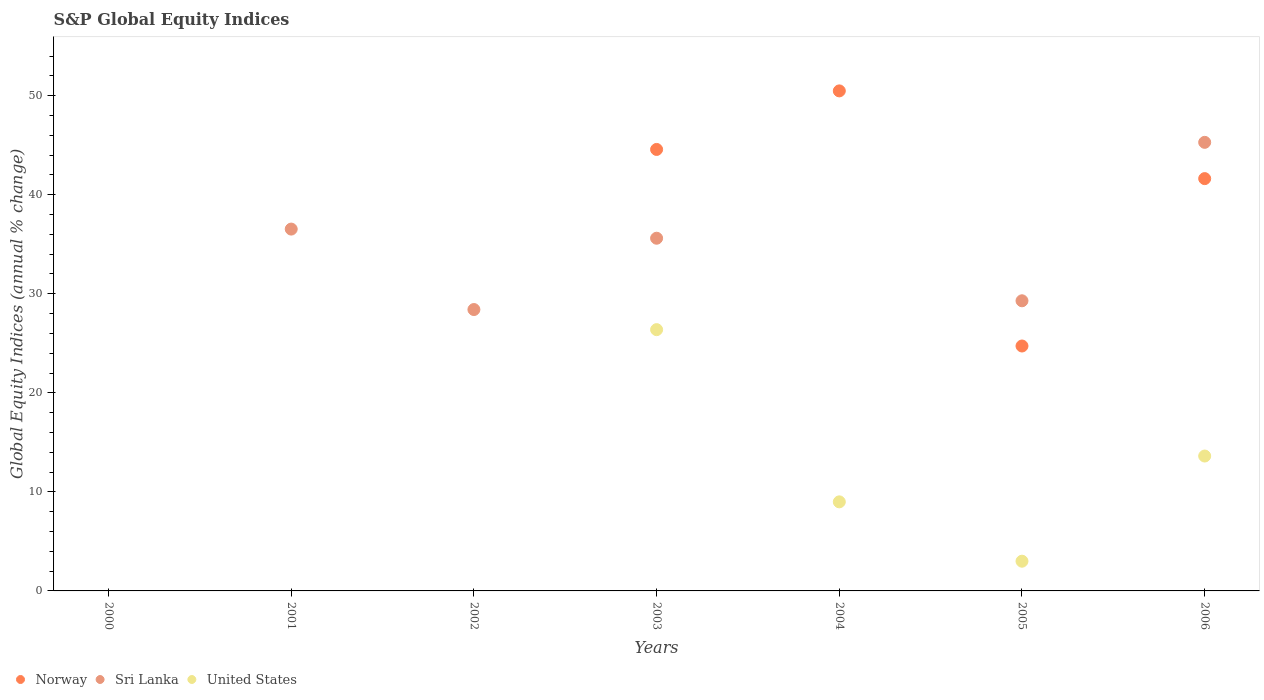How many different coloured dotlines are there?
Your answer should be compact. 3. Is the number of dotlines equal to the number of legend labels?
Your answer should be compact. No. Across all years, what is the maximum global equity indices in Sri Lanka?
Make the answer very short. 45.29. Across all years, what is the minimum global equity indices in Norway?
Your answer should be compact. 0. In which year was the global equity indices in United States maximum?
Your answer should be compact. 2003. What is the total global equity indices in United States in the graph?
Your response must be concise. 51.99. What is the difference between the global equity indices in Sri Lanka in 2003 and that in 2006?
Your answer should be compact. -9.68. What is the difference between the global equity indices in Sri Lanka in 2005 and the global equity indices in Norway in 2001?
Offer a very short reply. 29.29. What is the average global equity indices in Sri Lanka per year?
Offer a very short reply. 25.02. In the year 2003, what is the difference between the global equity indices in Norway and global equity indices in Sri Lanka?
Provide a short and direct response. 8.96. In how many years, is the global equity indices in United States greater than 52 %?
Offer a terse response. 0. What is the ratio of the global equity indices in United States in 2003 to that in 2005?
Make the answer very short. 8.79. Is the global equity indices in United States in 2004 less than that in 2005?
Ensure brevity in your answer.  No. What is the difference between the highest and the second highest global equity indices in United States?
Ensure brevity in your answer.  12.76. What is the difference between the highest and the lowest global equity indices in Sri Lanka?
Your response must be concise. 45.29. Is the global equity indices in United States strictly less than the global equity indices in Norway over the years?
Give a very brief answer. No. How many dotlines are there?
Make the answer very short. 3. How many years are there in the graph?
Ensure brevity in your answer.  7. Are the values on the major ticks of Y-axis written in scientific E-notation?
Provide a succinct answer. No. Does the graph contain any zero values?
Provide a short and direct response. Yes. Does the graph contain grids?
Ensure brevity in your answer.  No. How many legend labels are there?
Provide a succinct answer. 3. What is the title of the graph?
Offer a very short reply. S&P Global Equity Indices. Does "Togo" appear as one of the legend labels in the graph?
Provide a short and direct response. No. What is the label or title of the X-axis?
Make the answer very short. Years. What is the label or title of the Y-axis?
Give a very brief answer. Global Equity Indices (annual % change). What is the Global Equity Indices (annual % change) of Sri Lanka in 2000?
Offer a very short reply. 0. What is the Global Equity Indices (annual % change) in United States in 2000?
Make the answer very short. 0. What is the Global Equity Indices (annual % change) in Norway in 2001?
Make the answer very short. 0. What is the Global Equity Indices (annual % change) of Sri Lanka in 2001?
Offer a terse response. 36.53. What is the Global Equity Indices (annual % change) of United States in 2001?
Your answer should be compact. 0. What is the Global Equity Indices (annual % change) in Sri Lanka in 2002?
Your answer should be compact. 28.41. What is the Global Equity Indices (annual % change) of Norway in 2003?
Your answer should be very brief. 44.57. What is the Global Equity Indices (annual % change) in Sri Lanka in 2003?
Give a very brief answer. 35.61. What is the Global Equity Indices (annual % change) of United States in 2003?
Give a very brief answer. 26.38. What is the Global Equity Indices (annual % change) of Norway in 2004?
Your response must be concise. 50.49. What is the Global Equity Indices (annual % change) in United States in 2004?
Give a very brief answer. 8.99. What is the Global Equity Indices (annual % change) of Norway in 2005?
Give a very brief answer. 24.73. What is the Global Equity Indices (annual % change) of Sri Lanka in 2005?
Your response must be concise. 29.29. What is the Global Equity Indices (annual % change) in United States in 2005?
Offer a very short reply. 3. What is the Global Equity Indices (annual % change) in Norway in 2006?
Offer a terse response. 41.63. What is the Global Equity Indices (annual % change) in Sri Lanka in 2006?
Provide a succinct answer. 45.29. What is the Global Equity Indices (annual % change) in United States in 2006?
Your answer should be compact. 13.62. Across all years, what is the maximum Global Equity Indices (annual % change) of Norway?
Give a very brief answer. 50.49. Across all years, what is the maximum Global Equity Indices (annual % change) of Sri Lanka?
Provide a short and direct response. 45.29. Across all years, what is the maximum Global Equity Indices (annual % change) of United States?
Give a very brief answer. 26.38. Across all years, what is the minimum Global Equity Indices (annual % change) of Norway?
Make the answer very short. 0. Across all years, what is the minimum Global Equity Indices (annual % change) in Sri Lanka?
Make the answer very short. 0. Across all years, what is the minimum Global Equity Indices (annual % change) of United States?
Ensure brevity in your answer.  0. What is the total Global Equity Indices (annual % change) in Norway in the graph?
Give a very brief answer. 161.42. What is the total Global Equity Indices (annual % change) in Sri Lanka in the graph?
Give a very brief answer. 175.14. What is the total Global Equity Indices (annual % change) of United States in the graph?
Make the answer very short. 51.99. What is the difference between the Global Equity Indices (annual % change) in Sri Lanka in 2001 and that in 2002?
Your response must be concise. 8.12. What is the difference between the Global Equity Indices (annual % change) of Sri Lanka in 2001 and that in 2003?
Your response must be concise. 0.92. What is the difference between the Global Equity Indices (annual % change) of Sri Lanka in 2001 and that in 2005?
Keep it short and to the point. 7.24. What is the difference between the Global Equity Indices (annual % change) of Sri Lanka in 2001 and that in 2006?
Provide a succinct answer. -8.76. What is the difference between the Global Equity Indices (annual % change) in Sri Lanka in 2002 and that in 2005?
Your answer should be compact. -0.88. What is the difference between the Global Equity Indices (annual % change) of Sri Lanka in 2002 and that in 2006?
Give a very brief answer. -16.88. What is the difference between the Global Equity Indices (annual % change) in Norway in 2003 and that in 2004?
Provide a succinct answer. -5.91. What is the difference between the Global Equity Indices (annual % change) in United States in 2003 and that in 2004?
Your answer should be very brief. 17.39. What is the difference between the Global Equity Indices (annual % change) in Norway in 2003 and that in 2005?
Provide a succinct answer. 19.85. What is the difference between the Global Equity Indices (annual % change) in Sri Lanka in 2003 and that in 2005?
Your answer should be very brief. 6.32. What is the difference between the Global Equity Indices (annual % change) in United States in 2003 and that in 2005?
Provide a short and direct response. 23.38. What is the difference between the Global Equity Indices (annual % change) of Norway in 2003 and that in 2006?
Make the answer very short. 2.95. What is the difference between the Global Equity Indices (annual % change) in Sri Lanka in 2003 and that in 2006?
Offer a very short reply. -9.68. What is the difference between the Global Equity Indices (annual % change) in United States in 2003 and that in 2006?
Give a very brief answer. 12.76. What is the difference between the Global Equity Indices (annual % change) in Norway in 2004 and that in 2005?
Provide a short and direct response. 25.76. What is the difference between the Global Equity Indices (annual % change) of United States in 2004 and that in 2005?
Ensure brevity in your answer.  5.99. What is the difference between the Global Equity Indices (annual % change) of Norway in 2004 and that in 2006?
Offer a very short reply. 8.86. What is the difference between the Global Equity Indices (annual % change) in United States in 2004 and that in 2006?
Offer a terse response. -4.63. What is the difference between the Global Equity Indices (annual % change) of Norway in 2005 and that in 2006?
Provide a succinct answer. -16.9. What is the difference between the Global Equity Indices (annual % change) of Sri Lanka in 2005 and that in 2006?
Give a very brief answer. -16. What is the difference between the Global Equity Indices (annual % change) of United States in 2005 and that in 2006?
Keep it short and to the point. -10.62. What is the difference between the Global Equity Indices (annual % change) in Sri Lanka in 2001 and the Global Equity Indices (annual % change) in United States in 2003?
Give a very brief answer. 10.15. What is the difference between the Global Equity Indices (annual % change) of Sri Lanka in 2001 and the Global Equity Indices (annual % change) of United States in 2004?
Your response must be concise. 27.54. What is the difference between the Global Equity Indices (annual % change) in Sri Lanka in 2001 and the Global Equity Indices (annual % change) in United States in 2005?
Provide a succinct answer. 33.53. What is the difference between the Global Equity Indices (annual % change) of Sri Lanka in 2001 and the Global Equity Indices (annual % change) of United States in 2006?
Provide a short and direct response. 22.91. What is the difference between the Global Equity Indices (annual % change) of Sri Lanka in 2002 and the Global Equity Indices (annual % change) of United States in 2003?
Provide a succinct answer. 2.03. What is the difference between the Global Equity Indices (annual % change) in Sri Lanka in 2002 and the Global Equity Indices (annual % change) in United States in 2004?
Offer a terse response. 19.42. What is the difference between the Global Equity Indices (annual % change) in Sri Lanka in 2002 and the Global Equity Indices (annual % change) in United States in 2005?
Offer a terse response. 25.41. What is the difference between the Global Equity Indices (annual % change) of Sri Lanka in 2002 and the Global Equity Indices (annual % change) of United States in 2006?
Offer a very short reply. 14.79. What is the difference between the Global Equity Indices (annual % change) of Norway in 2003 and the Global Equity Indices (annual % change) of United States in 2004?
Your answer should be very brief. 35.58. What is the difference between the Global Equity Indices (annual % change) in Sri Lanka in 2003 and the Global Equity Indices (annual % change) in United States in 2004?
Give a very brief answer. 26.62. What is the difference between the Global Equity Indices (annual % change) of Norway in 2003 and the Global Equity Indices (annual % change) of Sri Lanka in 2005?
Make the answer very short. 15.28. What is the difference between the Global Equity Indices (annual % change) in Norway in 2003 and the Global Equity Indices (annual % change) in United States in 2005?
Your answer should be very brief. 41.57. What is the difference between the Global Equity Indices (annual % change) of Sri Lanka in 2003 and the Global Equity Indices (annual % change) of United States in 2005?
Provide a short and direct response. 32.61. What is the difference between the Global Equity Indices (annual % change) in Norway in 2003 and the Global Equity Indices (annual % change) in Sri Lanka in 2006?
Offer a terse response. -0.72. What is the difference between the Global Equity Indices (annual % change) in Norway in 2003 and the Global Equity Indices (annual % change) in United States in 2006?
Your answer should be compact. 30.96. What is the difference between the Global Equity Indices (annual % change) in Sri Lanka in 2003 and the Global Equity Indices (annual % change) in United States in 2006?
Keep it short and to the point. 21.99. What is the difference between the Global Equity Indices (annual % change) of Norway in 2004 and the Global Equity Indices (annual % change) of Sri Lanka in 2005?
Keep it short and to the point. 21.19. What is the difference between the Global Equity Indices (annual % change) in Norway in 2004 and the Global Equity Indices (annual % change) in United States in 2005?
Offer a very short reply. 47.48. What is the difference between the Global Equity Indices (annual % change) in Norway in 2004 and the Global Equity Indices (annual % change) in Sri Lanka in 2006?
Keep it short and to the point. 5.19. What is the difference between the Global Equity Indices (annual % change) in Norway in 2004 and the Global Equity Indices (annual % change) in United States in 2006?
Keep it short and to the point. 36.87. What is the difference between the Global Equity Indices (annual % change) of Norway in 2005 and the Global Equity Indices (annual % change) of Sri Lanka in 2006?
Offer a terse response. -20.56. What is the difference between the Global Equity Indices (annual % change) in Norway in 2005 and the Global Equity Indices (annual % change) in United States in 2006?
Make the answer very short. 11.11. What is the difference between the Global Equity Indices (annual % change) in Sri Lanka in 2005 and the Global Equity Indices (annual % change) in United States in 2006?
Provide a succinct answer. 15.67. What is the average Global Equity Indices (annual % change) of Norway per year?
Ensure brevity in your answer.  23.06. What is the average Global Equity Indices (annual % change) in Sri Lanka per year?
Your response must be concise. 25.02. What is the average Global Equity Indices (annual % change) in United States per year?
Provide a succinct answer. 7.43. In the year 2003, what is the difference between the Global Equity Indices (annual % change) in Norway and Global Equity Indices (annual % change) in Sri Lanka?
Your response must be concise. 8.96. In the year 2003, what is the difference between the Global Equity Indices (annual % change) in Norway and Global Equity Indices (annual % change) in United States?
Offer a very short reply. 18.19. In the year 2003, what is the difference between the Global Equity Indices (annual % change) of Sri Lanka and Global Equity Indices (annual % change) of United States?
Ensure brevity in your answer.  9.23. In the year 2004, what is the difference between the Global Equity Indices (annual % change) in Norway and Global Equity Indices (annual % change) in United States?
Your answer should be compact. 41.49. In the year 2005, what is the difference between the Global Equity Indices (annual % change) in Norway and Global Equity Indices (annual % change) in Sri Lanka?
Your answer should be very brief. -4.57. In the year 2005, what is the difference between the Global Equity Indices (annual % change) of Norway and Global Equity Indices (annual % change) of United States?
Offer a very short reply. 21.73. In the year 2005, what is the difference between the Global Equity Indices (annual % change) of Sri Lanka and Global Equity Indices (annual % change) of United States?
Provide a succinct answer. 26.29. In the year 2006, what is the difference between the Global Equity Indices (annual % change) in Norway and Global Equity Indices (annual % change) in Sri Lanka?
Provide a short and direct response. -3.66. In the year 2006, what is the difference between the Global Equity Indices (annual % change) in Norway and Global Equity Indices (annual % change) in United States?
Make the answer very short. 28.01. In the year 2006, what is the difference between the Global Equity Indices (annual % change) in Sri Lanka and Global Equity Indices (annual % change) in United States?
Offer a very short reply. 31.67. What is the ratio of the Global Equity Indices (annual % change) of Sri Lanka in 2001 to that in 2002?
Provide a succinct answer. 1.29. What is the ratio of the Global Equity Indices (annual % change) of Sri Lanka in 2001 to that in 2003?
Your answer should be compact. 1.03. What is the ratio of the Global Equity Indices (annual % change) of Sri Lanka in 2001 to that in 2005?
Keep it short and to the point. 1.25. What is the ratio of the Global Equity Indices (annual % change) in Sri Lanka in 2001 to that in 2006?
Your answer should be very brief. 0.81. What is the ratio of the Global Equity Indices (annual % change) in Sri Lanka in 2002 to that in 2003?
Keep it short and to the point. 0.8. What is the ratio of the Global Equity Indices (annual % change) of Sri Lanka in 2002 to that in 2005?
Ensure brevity in your answer.  0.97. What is the ratio of the Global Equity Indices (annual % change) of Sri Lanka in 2002 to that in 2006?
Your response must be concise. 0.63. What is the ratio of the Global Equity Indices (annual % change) of Norway in 2003 to that in 2004?
Make the answer very short. 0.88. What is the ratio of the Global Equity Indices (annual % change) in United States in 2003 to that in 2004?
Make the answer very short. 2.93. What is the ratio of the Global Equity Indices (annual % change) of Norway in 2003 to that in 2005?
Your answer should be very brief. 1.8. What is the ratio of the Global Equity Indices (annual % change) of Sri Lanka in 2003 to that in 2005?
Ensure brevity in your answer.  1.22. What is the ratio of the Global Equity Indices (annual % change) of United States in 2003 to that in 2005?
Give a very brief answer. 8.79. What is the ratio of the Global Equity Indices (annual % change) in Norway in 2003 to that in 2006?
Provide a short and direct response. 1.07. What is the ratio of the Global Equity Indices (annual % change) of Sri Lanka in 2003 to that in 2006?
Ensure brevity in your answer.  0.79. What is the ratio of the Global Equity Indices (annual % change) in United States in 2003 to that in 2006?
Offer a terse response. 1.94. What is the ratio of the Global Equity Indices (annual % change) of Norway in 2004 to that in 2005?
Give a very brief answer. 2.04. What is the ratio of the Global Equity Indices (annual % change) of United States in 2004 to that in 2005?
Keep it short and to the point. 3. What is the ratio of the Global Equity Indices (annual % change) of Norway in 2004 to that in 2006?
Offer a terse response. 1.21. What is the ratio of the Global Equity Indices (annual % change) in United States in 2004 to that in 2006?
Provide a succinct answer. 0.66. What is the ratio of the Global Equity Indices (annual % change) of Norway in 2005 to that in 2006?
Offer a very short reply. 0.59. What is the ratio of the Global Equity Indices (annual % change) in Sri Lanka in 2005 to that in 2006?
Your answer should be compact. 0.65. What is the ratio of the Global Equity Indices (annual % change) of United States in 2005 to that in 2006?
Provide a short and direct response. 0.22. What is the difference between the highest and the second highest Global Equity Indices (annual % change) of Norway?
Ensure brevity in your answer.  5.91. What is the difference between the highest and the second highest Global Equity Indices (annual % change) of Sri Lanka?
Your answer should be compact. 8.76. What is the difference between the highest and the second highest Global Equity Indices (annual % change) in United States?
Provide a succinct answer. 12.76. What is the difference between the highest and the lowest Global Equity Indices (annual % change) in Norway?
Provide a short and direct response. 50.49. What is the difference between the highest and the lowest Global Equity Indices (annual % change) in Sri Lanka?
Offer a terse response. 45.29. What is the difference between the highest and the lowest Global Equity Indices (annual % change) in United States?
Offer a terse response. 26.38. 